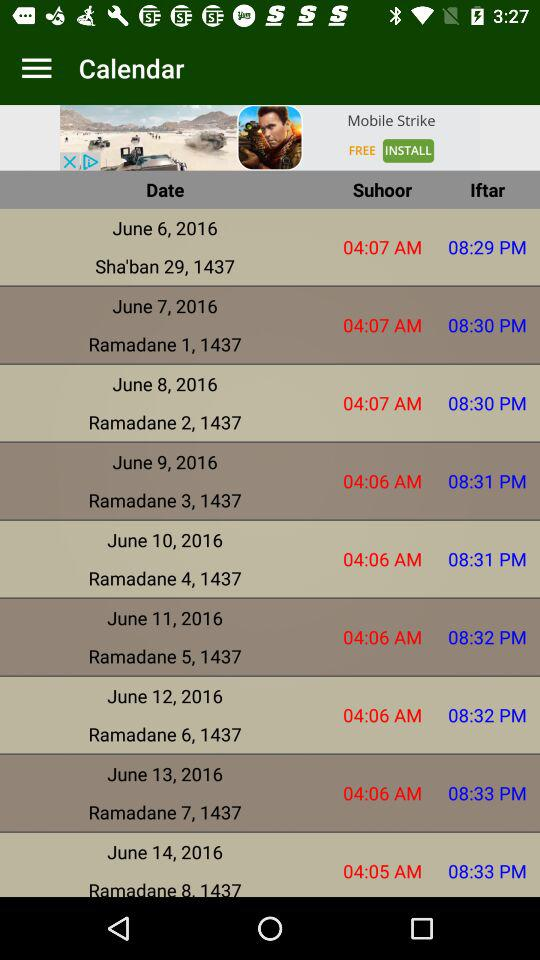What is the "Iftar" time for "Ramadane 2, 1437"? The time is 8:30 PM. 